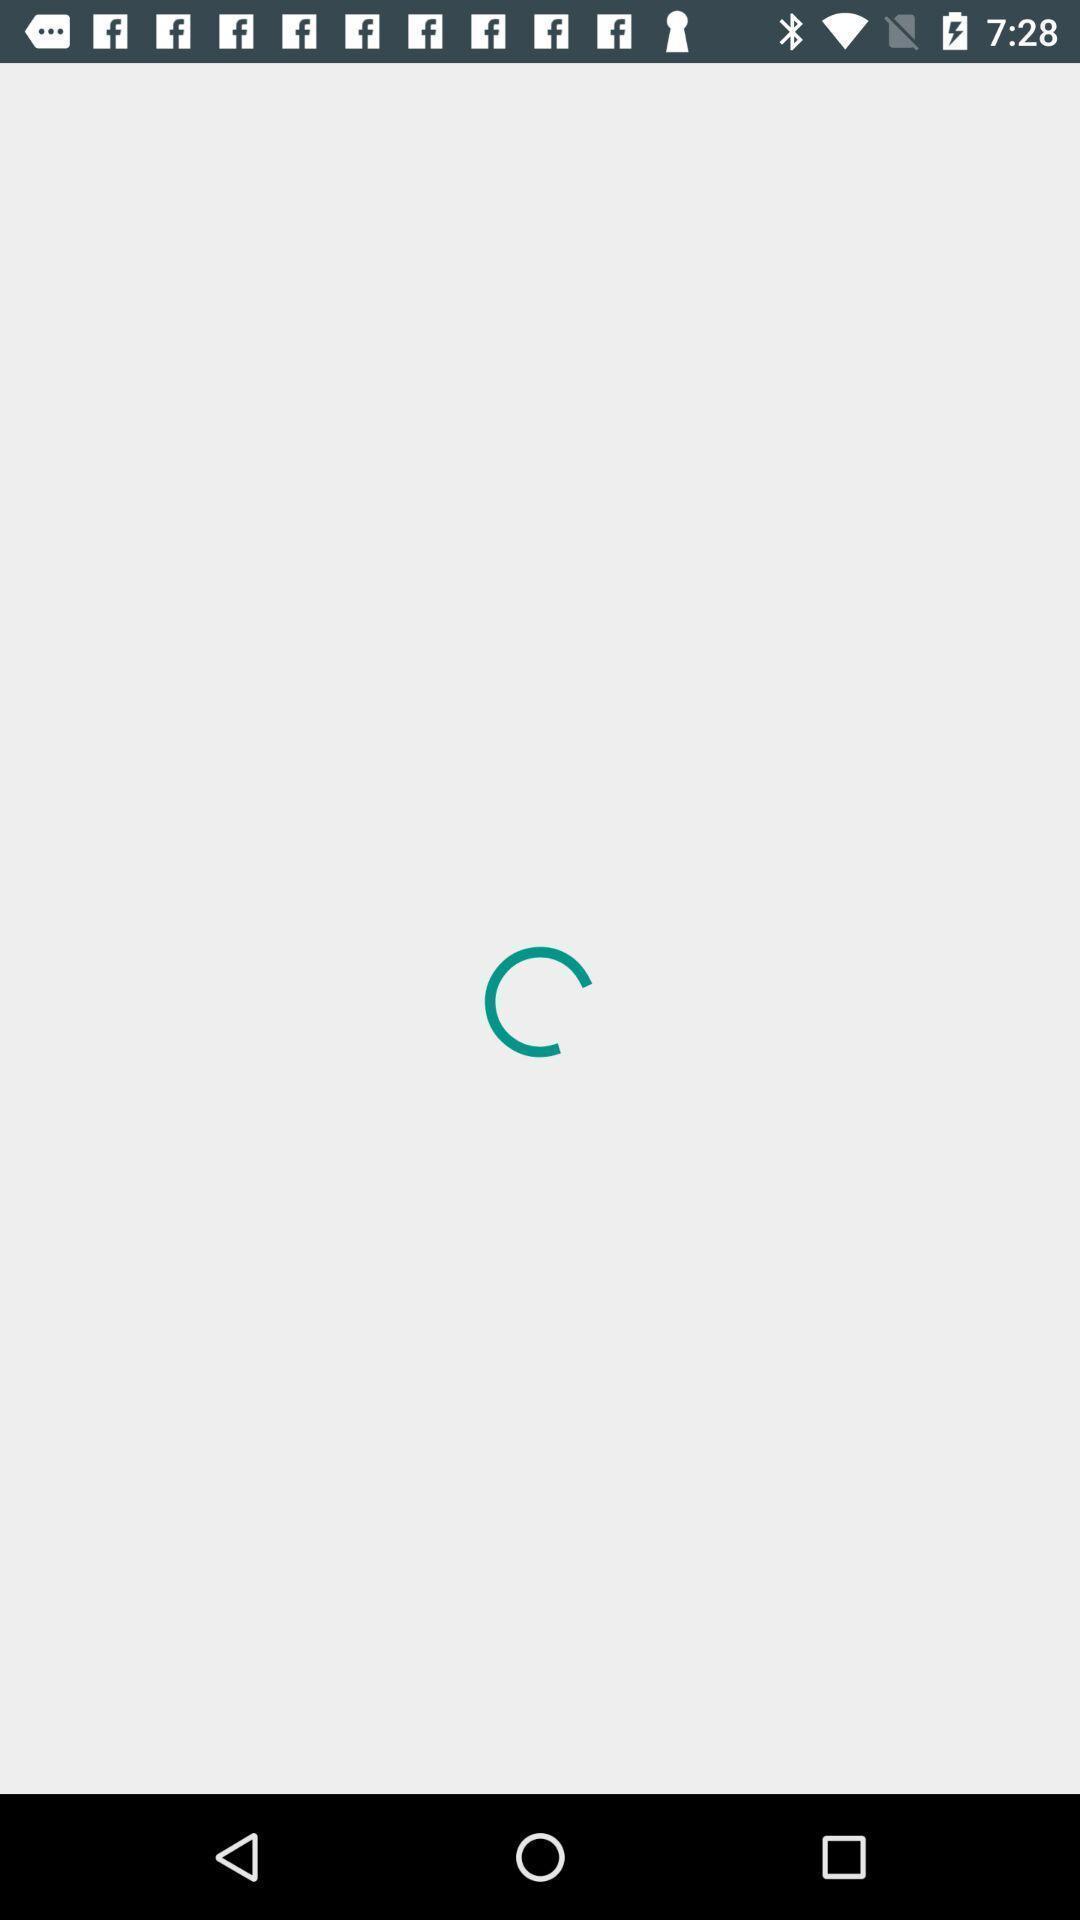Give me a summary of this screen capture. Screen showing loading page. 